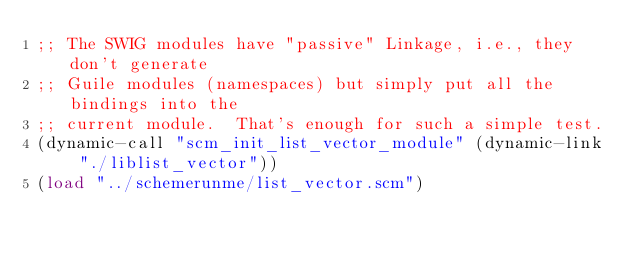Convert code to text. <code><loc_0><loc_0><loc_500><loc_500><_Scheme_>;; The SWIG modules have "passive" Linkage, i.e., they don't generate
;; Guile modules (namespaces) but simply put all the bindings into the
;; current module.  That's enough for such a simple test.
(dynamic-call "scm_init_list_vector_module" (dynamic-link "./liblist_vector"))
(load "../schemerunme/list_vector.scm")
</code> 